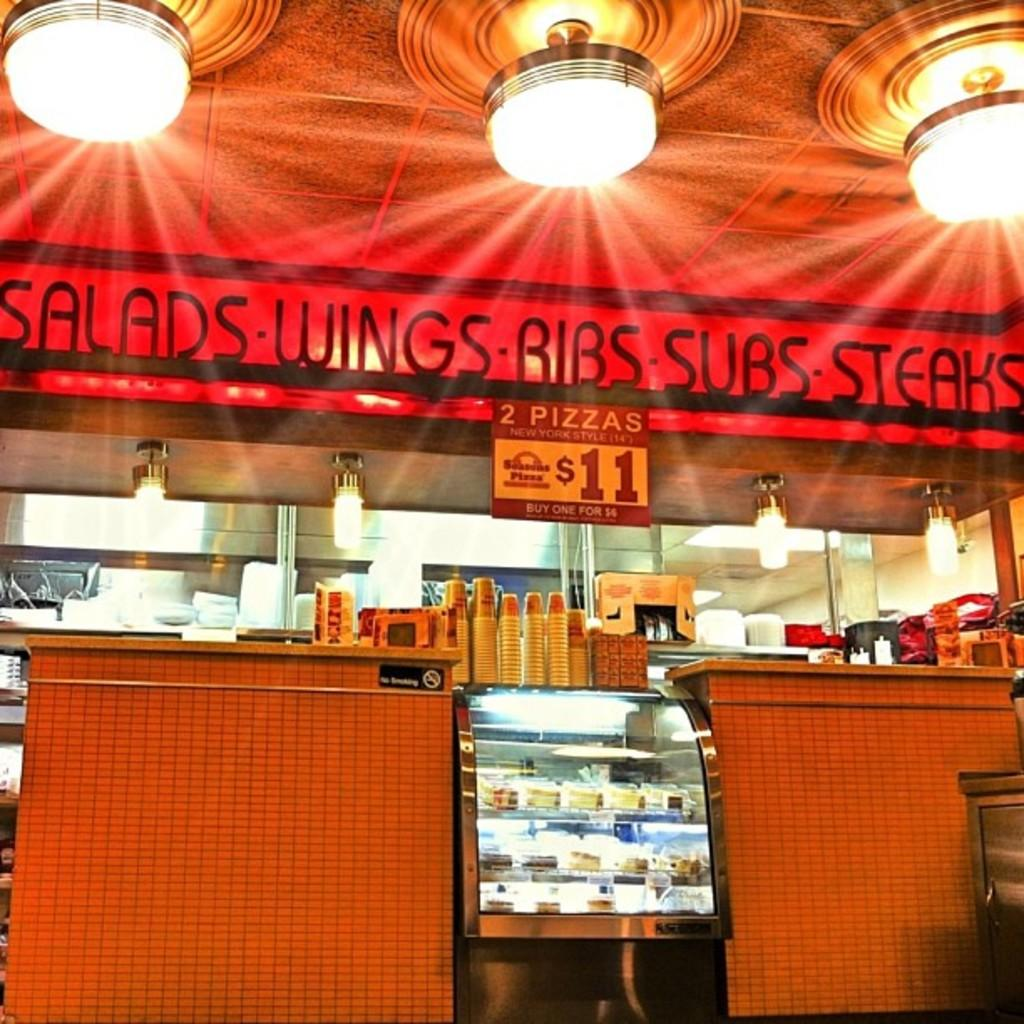<image>
Share a concise interpretation of the image provided. A restaurant with a sign that says 2 Pizzas for $11. 